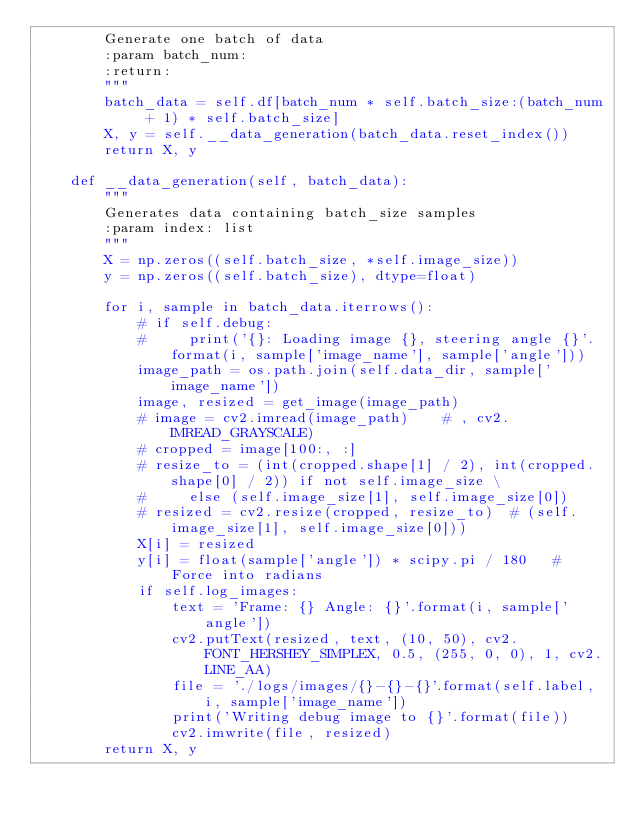<code> <loc_0><loc_0><loc_500><loc_500><_Python_>        Generate one batch of data
        :param batch_num:
        :return:
        """
        batch_data = self.df[batch_num * self.batch_size:(batch_num + 1) * self.batch_size]
        X, y = self.__data_generation(batch_data.reset_index())
        return X, y

    def __data_generation(self, batch_data):
        """
        Generates data containing batch_size samples
        :param index: list
        """
        X = np.zeros((self.batch_size, *self.image_size))
        y = np.zeros((self.batch_size), dtype=float)

        for i, sample in batch_data.iterrows():
            # if self.debug:
            #     print('{}: Loading image {}, steering angle {}'.format(i, sample['image_name'], sample['angle']))
            image_path = os.path.join(self.data_dir, sample['image_name'])
            image, resized = get_image(image_path)
            # image = cv2.imread(image_path)    # , cv2.IMREAD_GRAYSCALE)
            # cropped = image[100:, :]
            # resize_to = (int(cropped.shape[1] / 2), int(cropped.shape[0] / 2)) if not self.image_size \
            #     else (self.image_size[1], self.image_size[0])
            # resized = cv2.resize(cropped, resize_to)  # (self.image_size[1], self.image_size[0]))
            X[i] = resized
            y[i] = float(sample['angle']) * scipy.pi / 180   # Force into radians
            if self.log_images:
                text = 'Frame: {} Angle: {}'.format(i, sample['angle'])
                cv2.putText(resized, text, (10, 50), cv2.FONT_HERSHEY_SIMPLEX, 0.5, (255, 0, 0), 1, cv2.LINE_AA)
                file = './logs/images/{}-{}-{}'.format(self.label, i, sample['image_name'])
                print('Writing debug image to {}'.format(file))
                cv2.imwrite(file, resized)
        return X, y






</code> 